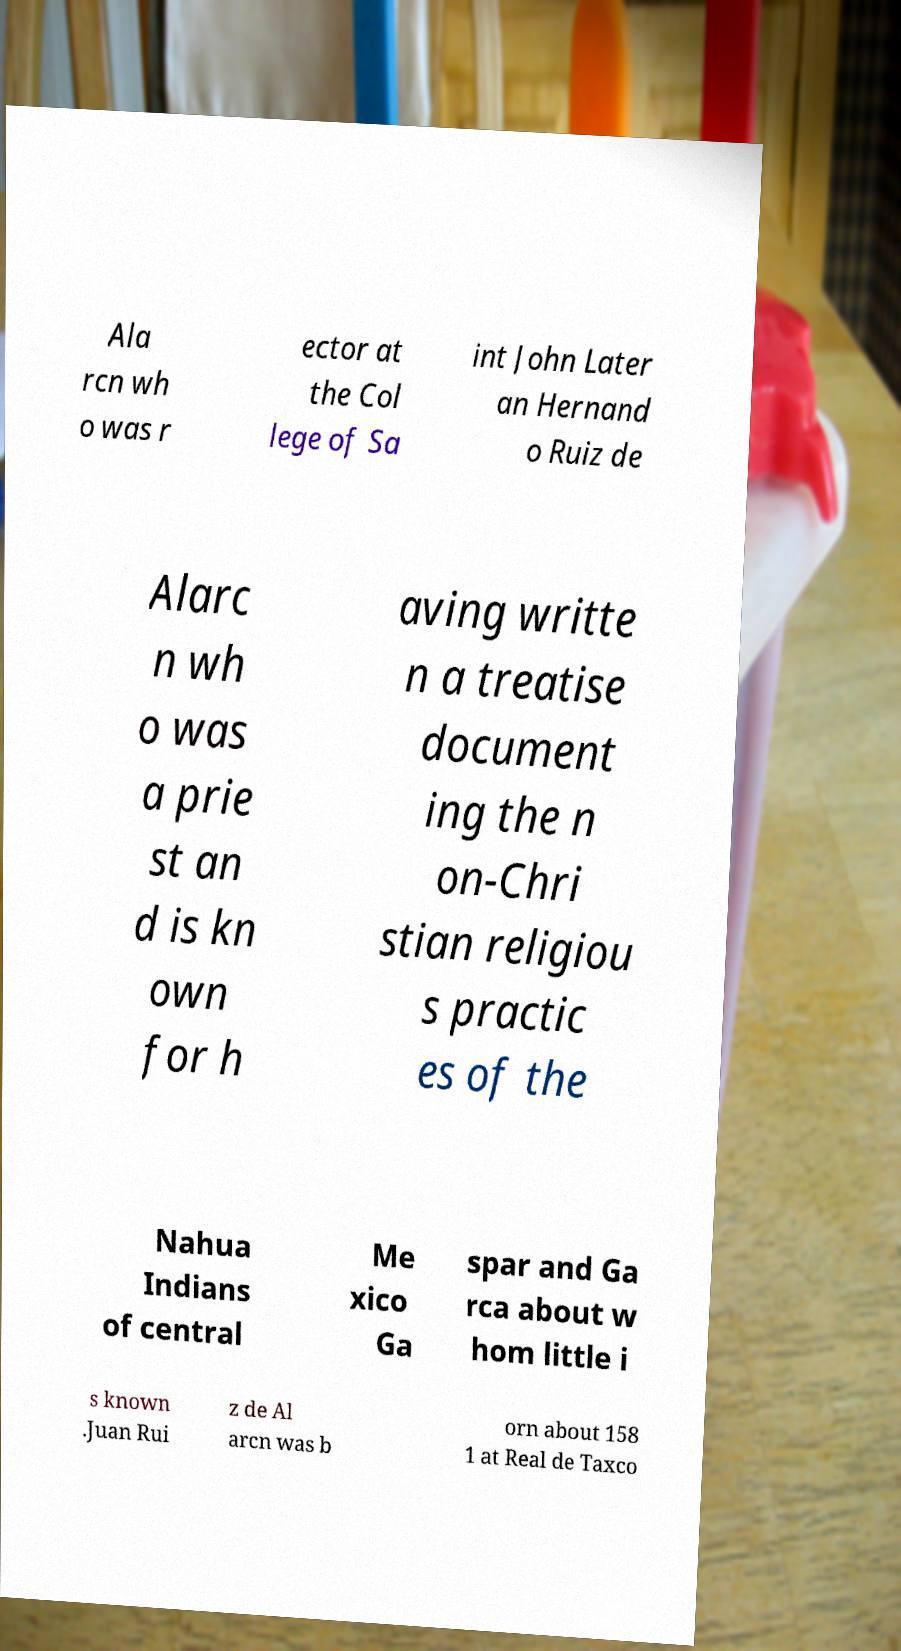There's text embedded in this image that I need extracted. Can you transcribe it verbatim? Ala rcn wh o was r ector at the Col lege of Sa int John Later an Hernand o Ruiz de Alarc n wh o was a prie st an d is kn own for h aving writte n a treatise document ing the n on-Chri stian religiou s practic es of the Nahua Indians of central Me xico Ga spar and Ga rca about w hom little i s known .Juan Rui z de Al arcn was b orn about 158 1 at Real de Taxco 